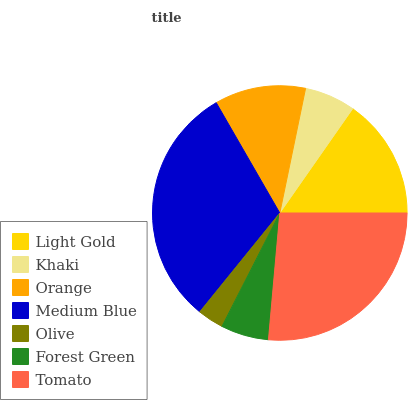Is Olive the minimum?
Answer yes or no. Yes. Is Medium Blue the maximum?
Answer yes or no. Yes. Is Khaki the minimum?
Answer yes or no. No. Is Khaki the maximum?
Answer yes or no. No. Is Light Gold greater than Khaki?
Answer yes or no. Yes. Is Khaki less than Light Gold?
Answer yes or no. Yes. Is Khaki greater than Light Gold?
Answer yes or no. No. Is Light Gold less than Khaki?
Answer yes or no. No. Is Orange the high median?
Answer yes or no. Yes. Is Orange the low median?
Answer yes or no. Yes. Is Khaki the high median?
Answer yes or no. No. Is Tomato the low median?
Answer yes or no. No. 